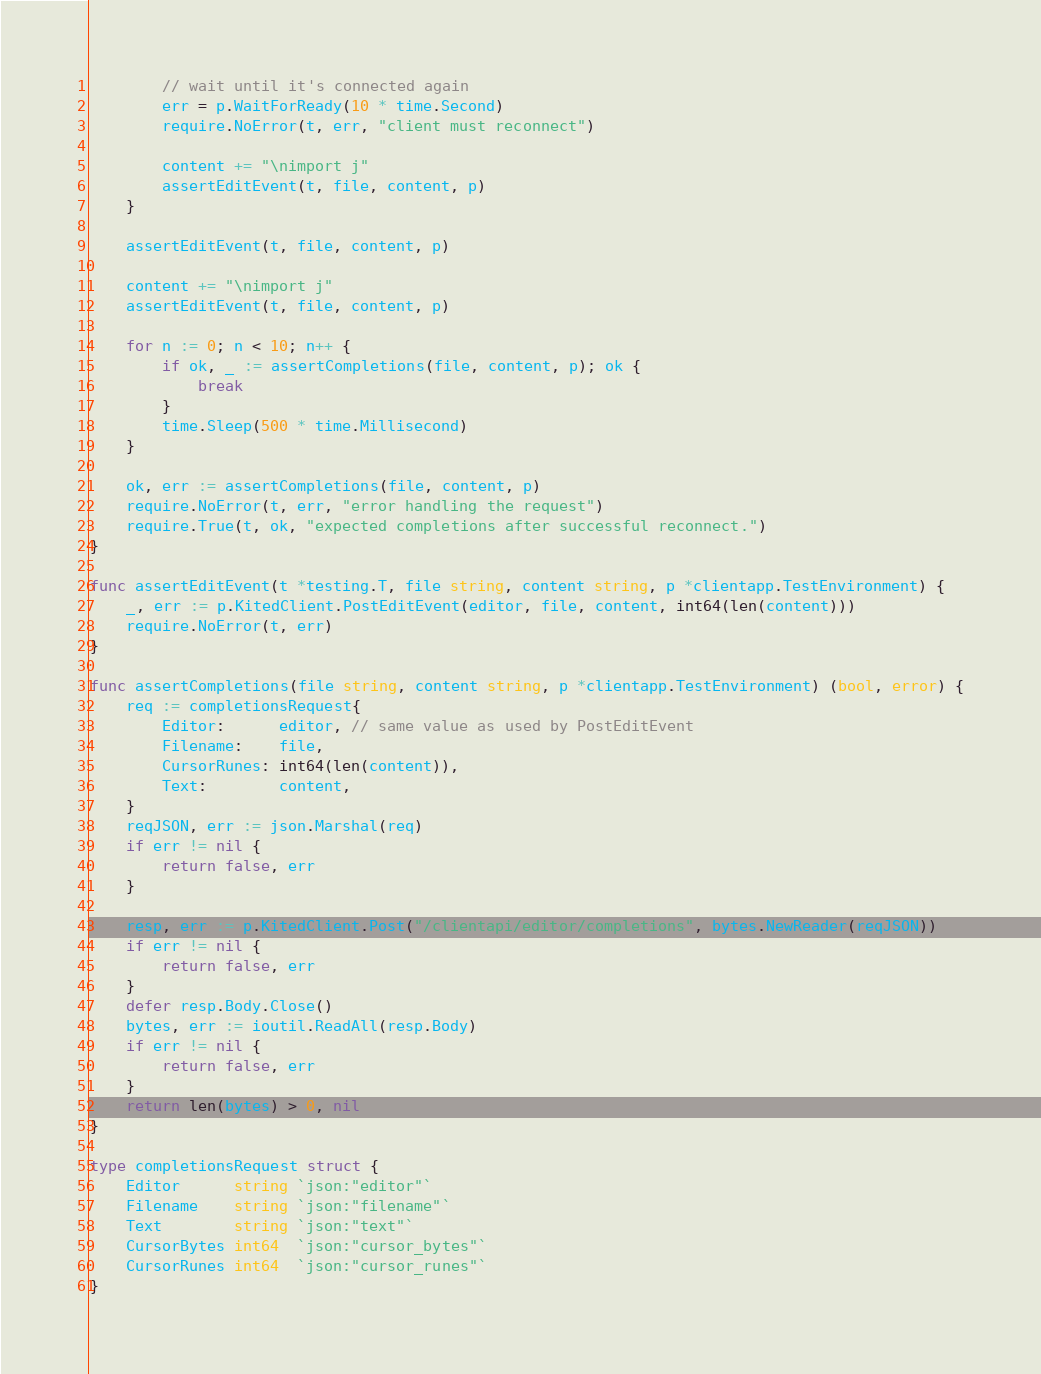<code> <loc_0><loc_0><loc_500><loc_500><_Go_>		// wait until it's connected again
		err = p.WaitForReady(10 * time.Second)
		require.NoError(t, err, "client must reconnect")

		content += "\nimport j"
		assertEditEvent(t, file, content, p)
	}

	assertEditEvent(t, file, content, p)

	content += "\nimport j"
	assertEditEvent(t, file, content, p)

	for n := 0; n < 10; n++ {
		if ok, _ := assertCompletions(file, content, p); ok {
			break
		}
		time.Sleep(500 * time.Millisecond)
	}

	ok, err := assertCompletions(file, content, p)
	require.NoError(t, err, "error handling the request")
	require.True(t, ok, "expected completions after successful reconnect.")
}

func assertEditEvent(t *testing.T, file string, content string, p *clientapp.TestEnvironment) {
	_, err := p.KitedClient.PostEditEvent(editor, file, content, int64(len(content)))
	require.NoError(t, err)
}

func assertCompletions(file string, content string, p *clientapp.TestEnvironment) (bool, error) {
	req := completionsRequest{
		Editor:      editor, // same value as used by PostEditEvent
		Filename:    file,
		CursorRunes: int64(len(content)),
		Text:        content,
	}
	reqJSON, err := json.Marshal(req)
	if err != nil {
		return false, err
	}

	resp, err := p.KitedClient.Post("/clientapi/editor/completions", bytes.NewReader(reqJSON))
	if err != nil {
		return false, err
	}
	defer resp.Body.Close()
	bytes, err := ioutil.ReadAll(resp.Body)
	if err != nil {
		return false, err
	}
	return len(bytes) > 0, nil
}

type completionsRequest struct {
	Editor      string `json:"editor"`
	Filename    string `json:"filename"`
	Text        string `json:"text"`
	CursorBytes int64  `json:"cursor_bytes"`
	CursorRunes int64  `json:"cursor_runes"`
}
</code> 